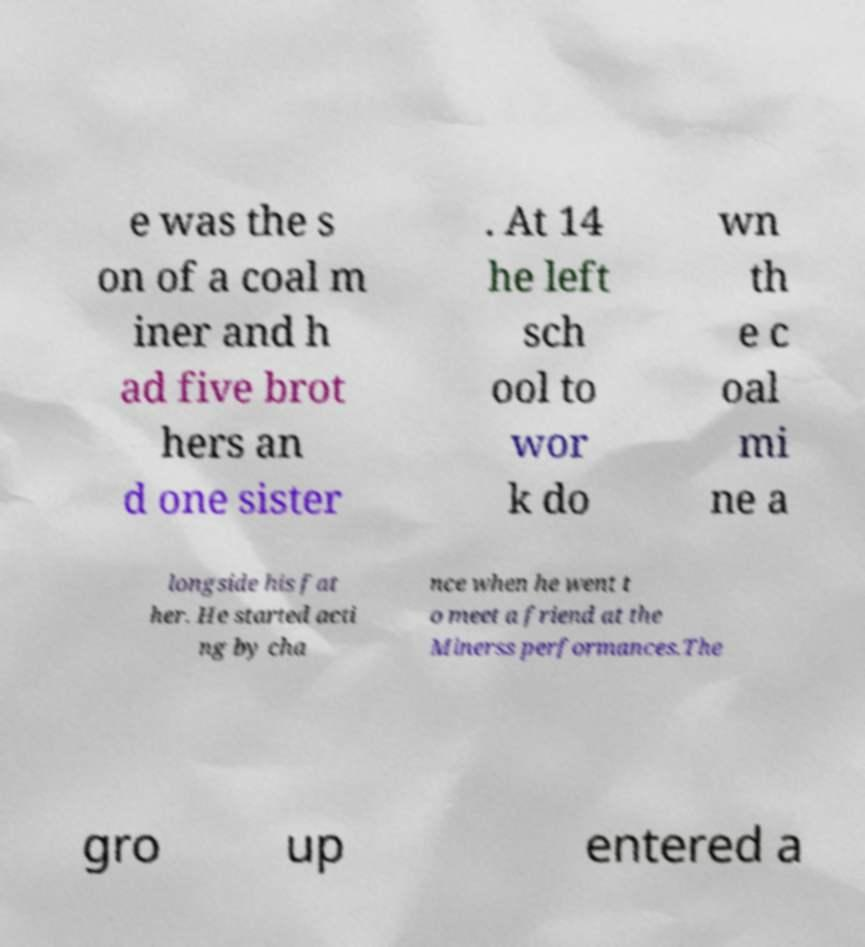Could you extract and type out the text from this image? e was the s on of a coal m iner and h ad five brot hers an d one sister . At 14 he left sch ool to wor k do wn th e c oal mi ne a longside his fat her. He started acti ng by cha nce when he went t o meet a friend at the Minerss performances.The gro up entered a 